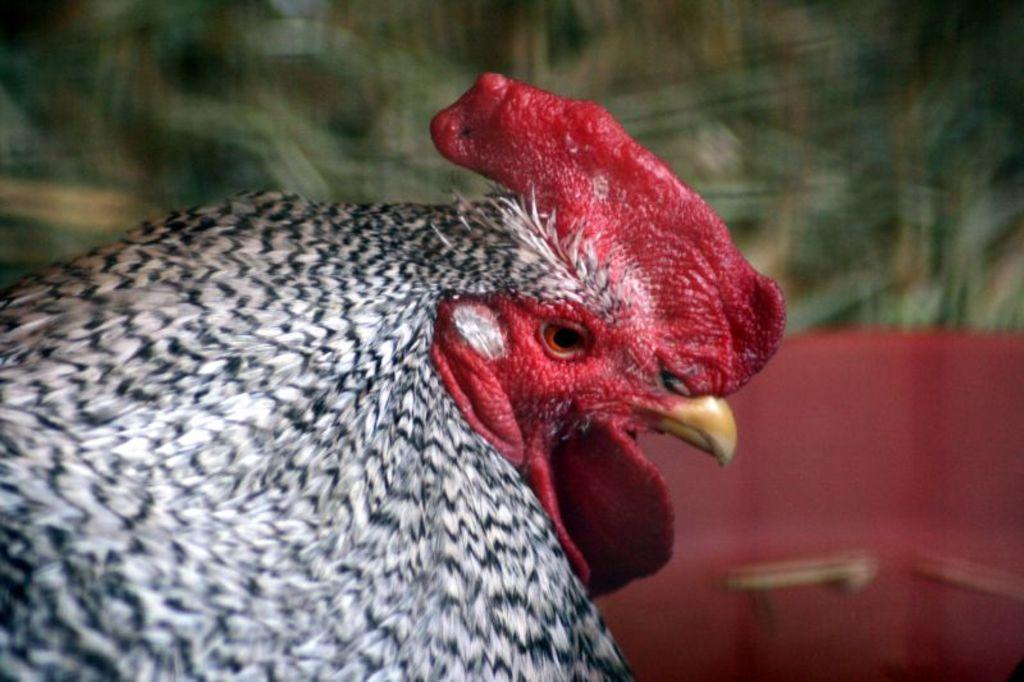What animal is the main subject of the picture? There is a hen in the picture. Can you describe the background of the image? The background of the image is blurred. How many bears are sitting on the tree in the image? There are no bears or trees present in the image; it features a hen with a blurred background. 